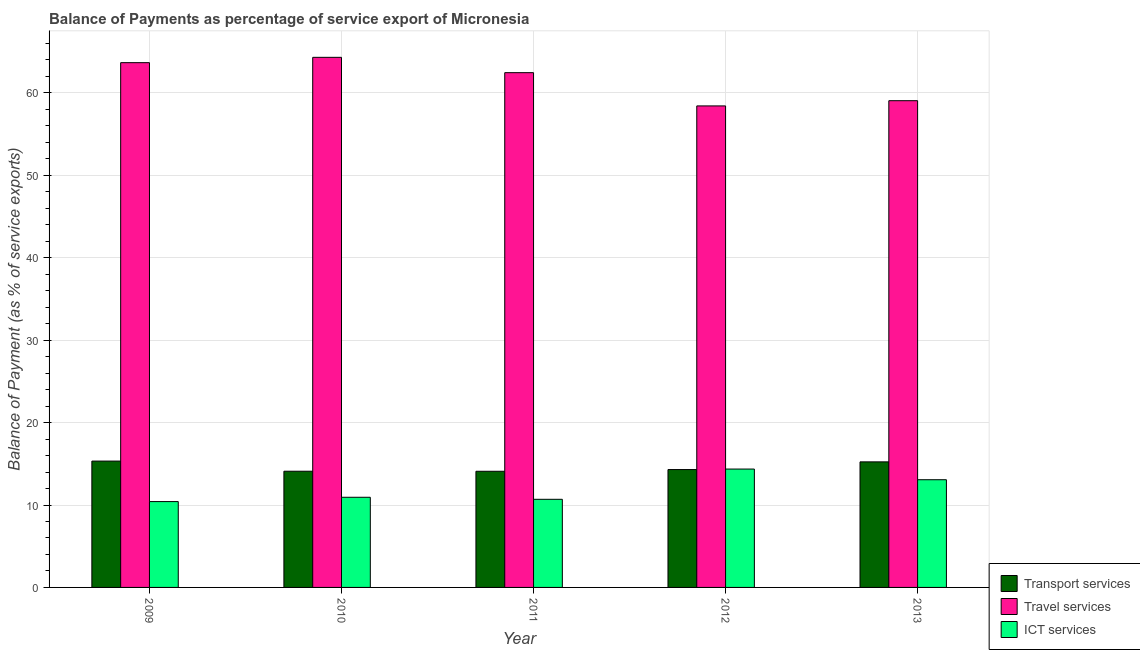How many groups of bars are there?
Offer a terse response. 5. Are the number of bars per tick equal to the number of legend labels?
Keep it short and to the point. Yes. Are the number of bars on each tick of the X-axis equal?
Keep it short and to the point. Yes. How many bars are there on the 3rd tick from the left?
Your answer should be very brief. 3. In how many cases, is the number of bars for a given year not equal to the number of legend labels?
Your response must be concise. 0. What is the balance of payment of travel services in 2013?
Your response must be concise. 59.06. Across all years, what is the maximum balance of payment of ict services?
Your response must be concise. 14.36. Across all years, what is the minimum balance of payment of travel services?
Your answer should be very brief. 58.43. In which year was the balance of payment of ict services minimum?
Give a very brief answer. 2009. What is the total balance of payment of travel services in the graph?
Offer a terse response. 307.94. What is the difference between the balance of payment of transport services in 2011 and that in 2013?
Give a very brief answer. -1.14. What is the difference between the balance of payment of transport services in 2010 and the balance of payment of ict services in 2012?
Keep it short and to the point. -0.2. What is the average balance of payment of travel services per year?
Provide a succinct answer. 61.59. In the year 2010, what is the difference between the balance of payment of travel services and balance of payment of ict services?
Offer a terse response. 0. In how many years, is the balance of payment of ict services greater than 44 %?
Ensure brevity in your answer.  0. What is the ratio of the balance of payment of travel services in 2009 to that in 2010?
Ensure brevity in your answer.  0.99. What is the difference between the highest and the second highest balance of payment of travel services?
Your answer should be compact. 0.65. What is the difference between the highest and the lowest balance of payment of travel services?
Offer a very short reply. 5.89. In how many years, is the balance of payment of transport services greater than the average balance of payment of transport services taken over all years?
Give a very brief answer. 2. Is the sum of the balance of payment of travel services in 2011 and 2013 greater than the maximum balance of payment of ict services across all years?
Offer a very short reply. Yes. What does the 1st bar from the left in 2013 represents?
Provide a succinct answer. Transport services. What does the 2nd bar from the right in 2010 represents?
Offer a terse response. Travel services. How many bars are there?
Give a very brief answer. 15. Are all the bars in the graph horizontal?
Your answer should be compact. No. How many years are there in the graph?
Make the answer very short. 5. What is the difference between two consecutive major ticks on the Y-axis?
Your response must be concise. 10. Does the graph contain grids?
Keep it short and to the point. Yes. What is the title of the graph?
Make the answer very short. Balance of Payments as percentage of service export of Micronesia. Does "Total employers" appear as one of the legend labels in the graph?
Your answer should be very brief. No. What is the label or title of the Y-axis?
Your answer should be compact. Balance of Payment (as % of service exports). What is the Balance of Payment (as % of service exports) in Transport services in 2009?
Your response must be concise. 15.33. What is the Balance of Payment (as % of service exports) in Travel services in 2009?
Offer a terse response. 63.67. What is the Balance of Payment (as % of service exports) of ICT services in 2009?
Offer a very short reply. 10.42. What is the Balance of Payment (as % of service exports) in Transport services in 2010?
Your answer should be compact. 14.1. What is the Balance of Payment (as % of service exports) of Travel services in 2010?
Provide a short and direct response. 64.32. What is the Balance of Payment (as % of service exports) in ICT services in 2010?
Offer a very short reply. 10.94. What is the Balance of Payment (as % of service exports) of Transport services in 2011?
Make the answer very short. 14.09. What is the Balance of Payment (as % of service exports) in Travel services in 2011?
Your response must be concise. 62.46. What is the Balance of Payment (as % of service exports) in ICT services in 2011?
Give a very brief answer. 10.69. What is the Balance of Payment (as % of service exports) of Transport services in 2012?
Ensure brevity in your answer.  14.3. What is the Balance of Payment (as % of service exports) of Travel services in 2012?
Your response must be concise. 58.43. What is the Balance of Payment (as % of service exports) of ICT services in 2012?
Offer a very short reply. 14.36. What is the Balance of Payment (as % of service exports) in Transport services in 2013?
Your response must be concise. 15.23. What is the Balance of Payment (as % of service exports) in Travel services in 2013?
Your answer should be compact. 59.06. What is the Balance of Payment (as % of service exports) in ICT services in 2013?
Provide a short and direct response. 13.07. Across all years, what is the maximum Balance of Payment (as % of service exports) of Transport services?
Your answer should be compact. 15.33. Across all years, what is the maximum Balance of Payment (as % of service exports) in Travel services?
Your answer should be compact. 64.32. Across all years, what is the maximum Balance of Payment (as % of service exports) of ICT services?
Provide a succinct answer. 14.36. Across all years, what is the minimum Balance of Payment (as % of service exports) in Transport services?
Provide a succinct answer. 14.09. Across all years, what is the minimum Balance of Payment (as % of service exports) in Travel services?
Provide a succinct answer. 58.43. Across all years, what is the minimum Balance of Payment (as % of service exports) in ICT services?
Offer a terse response. 10.42. What is the total Balance of Payment (as % of service exports) of Transport services in the graph?
Keep it short and to the point. 73.06. What is the total Balance of Payment (as % of service exports) in Travel services in the graph?
Make the answer very short. 307.94. What is the total Balance of Payment (as % of service exports) in ICT services in the graph?
Ensure brevity in your answer.  59.48. What is the difference between the Balance of Payment (as % of service exports) in Transport services in 2009 and that in 2010?
Offer a very short reply. 1.23. What is the difference between the Balance of Payment (as % of service exports) in Travel services in 2009 and that in 2010?
Your answer should be very brief. -0.65. What is the difference between the Balance of Payment (as % of service exports) in ICT services in 2009 and that in 2010?
Keep it short and to the point. -0.52. What is the difference between the Balance of Payment (as % of service exports) of Transport services in 2009 and that in 2011?
Give a very brief answer. 1.24. What is the difference between the Balance of Payment (as % of service exports) of Travel services in 2009 and that in 2011?
Provide a short and direct response. 1.22. What is the difference between the Balance of Payment (as % of service exports) in ICT services in 2009 and that in 2011?
Make the answer very short. -0.28. What is the difference between the Balance of Payment (as % of service exports) of Transport services in 2009 and that in 2012?
Offer a very short reply. 1.03. What is the difference between the Balance of Payment (as % of service exports) in Travel services in 2009 and that in 2012?
Provide a succinct answer. 5.25. What is the difference between the Balance of Payment (as % of service exports) in ICT services in 2009 and that in 2012?
Your answer should be very brief. -3.95. What is the difference between the Balance of Payment (as % of service exports) in Transport services in 2009 and that in 2013?
Ensure brevity in your answer.  0.1. What is the difference between the Balance of Payment (as % of service exports) of Travel services in 2009 and that in 2013?
Make the answer very short. 4.62. What is the difference between the Balance of Payment (as % of service exports) of ICT services in 2009 and that in 2013?
Your response must be concise. -2.65. What is the difference between the Balance of Payment (as % of service exports) in Transport services in 2010 and that in 2011?
Offer a terse response. 0.01. What is the difference between the Balance of Payment (as % of service exports) in Travel services in 2010 and that in 2011?
Offer a very short reply. 1.86. What is the difference between the Balance of Payment (as % of service exports) of ICT services in 2010 and that in 2011?
Your answer should be compact. 0.25. What is the difference between the Balance of Payment (as % of service exports) of Transport services in 2010 and that in 2012?
Make the answer very short. -0.2. What is the difference between the Balance of Payment (as % of service exports) of Travel services in 2010 and that in 2012?
Make the answer very short. 5.89. What is the difference between the Balance of Payment (as % of service exports) of ICT services in 2010 and that in 2012?
Give a very brief answer. -3.42. What is the difference between the Balance of Payment (as % of service exports) of Transport services in 2010 and that in 2013?
Give a very brief answer. -1.14. What is the difference between the Balance of Payment (as % of service exports) in Travel services in 2010 and that in 2013?
Your answer should be compact. 5.26. What is the difference between the Balance of Payment (as % of service exports) in ICT services in 2010 and that in 2013?
Ensure brevity in your answer.  -2.13. What is the difference between the Balance of Payment (as % of service exports) of Transport services in 2011 and that in 2012?
Offer a very short reply. -0.21. What is the difference between the Balance of Payment (as % of service exports) of Travel services in 2011 and that in 2012?
Provide a succinct answer. 4.03. What is the difference between the Balance of Payment (as % of service exports) of ICT services in 2011 and that in 2012?
Your answer should be compact. -3.67. What is the difference between the Balance of Payment (as % of service exports) in Transport services in 2011 and that in 2013?
Provide a short and direct response. -1.14. What is the difference between the Balance of Payment (as % of service exports) in Travel services in 2011 and that in 2013?
Provide a short and direct response. 3.4. What is the difference between the Balance of Payment (as % of service exports) of ICT services in 2011 and that in 2013?
Offer a terse response. -2.38. What is the difference between the Balance of Payment (as % of service exports) in Transport services in 2012 and that in 2013?
Provide a succinct answer. -0.93. What is the difference between the Balance of Payment (as % of service exports) of Travel services in 2012 and that in 2013?
Give a very brief answer. -0.63. What is the difference between the Balance of Payment (as % of service exports) in ICT services in 2012 and that in 2013?
Provide a short and direct response. 1.29. What is the difference between the Balance of Payment (as % of service exports) of Transport services in 2009 and the Balance of Payment (as % of service exports) of Travel services in 2010?
Offer a terse response. -48.99. What is the difference between the Balance of Payment (as % of service exports) of Transport services in 2009 and the Balance of Payment (as % of service exports) of ICT services in 2010?
Your answer should be compact. 4.39. What is the difference between the Balance of Payment (as % of service exports) in Travel services in 2009 and the Balance of Payment (as % of service exports) in ICT services in 2010?
Make the answer very short. 52.74. What is the difference between the Balance of Payment (as % of service exports) of Transport services in 2009 and the Balance of Payment (as % of service exports) of Travel services in 2011?
Your response must be concise. -47.13. What is the difference between the Balance of Payment (as % of service exports) of Transport services in 2009 and the Balance of Payment (as % of service exports) of ICT services in 2011?
Your response must be concise. 4.64. What is the difference between the Balance of Payment (as % of service exports) of Travel services in 2009 and the Balance of Payment (as % of service exports) of ICT services in 2011?
Your response must be concise. 52.98. What is the difference between the Balance of Payment (as % of service exports) in Transport services in 2009 and the Balance of Payment (as % of service exports) in Travel services in 2012?
Your answer should be compact. -43.1. What is the difference between the Balance of Payment (as % of service exports) in Transport services in 2009 and the Balance of Payment (as % of service exports) in ICT services in 2012?
Make the answer very short. 0.97. What is the difference between the Balance of Payment (as % of service exports) in Travel services in 2009 and the Balance of Payment (as % of service exports) in ICT services in 2012?
Your response must be concise. 49.31. What is the difference between the Balance of Payment (as % of service exports) of Transport services in 2009 and the Balance of Payment (as % of service exports) of Travel services in 2013?
Your response must be concise. -43.73. What is the difference between the Balance of Payment (as % of service exports) of Transport services in 2009 and the Balance of Payment (as % of service exports) of ICT services in 2013?
Your answer should be very brief. 2.26. What is the difference between the Balance of Payment (as % of service exports) of Travel services in 2009 and the Balance of Payment (as % of service exports) of ICT services in 2013?
Offer a terse response. 50.61. What is the difference between the Balance of Payment (as % of service exports) in Transport services in 2010 and the Balance of Payment (as % of service exports) in Travel services in 2011?
Keep it short and to the point. -48.36. What is the difference between the Balance of Payment (as % of service exports) in Transport services in 2010 and the Balance of Payment (as % of service exports) in ICT services in 2011?
Keep it short and to the point. 3.41. What is the difference between the Balance of Payment (as % of service exports) in Travel services in 2010 and the Balance of Payment (as % of service exports) in ICT services in 2011?
Offer a very short reply. 53.63. What is the difference between the Balance of Payment (as % of service exports) of Transport services in 2010 and the Balance of Payment (as % of service exports) of Travel services in 2012?
Offer a terse response. -44.33. What is the difference between the Balance of Payment (as % of service exports) of Transport services in 2010 and the Balance of Payment (as % of service exports) of ICT services in 2012?
Provide a succinct answer. -0.26. What is the difference between the Balance of Payment (as % of service exports) of Travel services in 2010 and the Balance of Payment (as % of service exports) of ICT services in 2012?
Your answer should be very brief. 49.96. What is the difference between the Balance of Payment (as % of service exports) in Transport services in 2010 and the Balance of Payment (as % of service exports) in Travel services in 2013?
Your answer should be very brief. -44.96. What is the difference between the Balance of Payment (as % of service exports) in Transport services in 2010 and the Balance of Payment (as % of service exports) in ICT services in 2013?
Provide a short and direct response. 1.03. What is the difference between the Balance of Payment (as % of service exports) of Travel services in 2010 and the Balance of Payment (as % of service exports) of ICT services in 2013?
Ensure brevity in your answer.  51.25. What is the difference between the Balance of Payment (as % of service exports) in Transport services in 2011 and the Balance of Payment (as % of service exports) in Travel services in 2012?
Ensure brevity in your answer.  -44.33. What is the difference between the Balance of Payment (as % of service exports) of Transport services in 2011 and the Balance of Payment (as % of service exports) of ICT services in 2012?
Offer a terse response. -0.27. What is the difference between the Balance of Payment (as % of service exports) of Travel services in 2011 and the Balance of Payment (as % of service exports) of ICT services in 2012?
Make the answer very short. 48.1. What is the difference between the Balance of Payment (as % of service exports) of Transport services in 2011 and the Balance of Payment (as % of service exports) of Travel services in 2013?
Your answer should be compact. -44.96. What is the difference between the Balance of Payment (as % of service exports) of Transport services in 2011 and the Balance of Payment (as % of service exports) of ICT services in 2013?
Your answer should be compact. 1.03. What is the difference between the Balance of Payment (as % of service exports) of Travel services in 2011 and the Balance of Payment (as % of service exports) of ICT services in 2013?
Your answer should be compact. 49.39. What is the difference between the Balance of Payment (as % of service exports) in Transport services in 2012 and the Balance of Payment (as % of service exports) in Travel services in 2013?
Give a very brief answer. -44.76. What is the difference between the Balance of Payment (as % of service exports) in Transport services in 2012 and the Balance of Payment (as % of service exports) in ICT services in 2013?
Make the answer very short. 1.23. What is the difference between the Balance of Payment (as % of service exports) of Travel services in 2012 and the Balance of Payment (as % of service exports) of ICT services in 2013?
Keep it short and to the point. 45.36. What is the average Balance of Payment (as % of service exports) in Transport services per year?
Your answer should be very brief. 14.61. What is the average Balance of Payment (as % of service exports) in Travel services per year?
Offer a very short reply. 61.59. What is the average Balance of Payment (as % of service exports) in ICT services per year?
Offer a very short reply. 11.9. In the year 2009, what is the difference between the Balance of Payment (as % of service exports) in Transport services and Balance of Payment (as % of service exports) in Travel services?
Your answer should be very brief. -48.34. In the year 2009, what is the difference between the Balance of Payment (as % of service exports) in Transport services and Balance of Payment (as % of service exports) in ICT services?
Ensure brevity in your answer.  4.91. In the year 2009, what is the difference between the Balance of Payment (as % of service exports) in Travel services and Balance of Payment (as % of service exports) in ICT services?
Your response must be concise. 53.26. In the year 2010, what is the difference between the Balance of Payment (as % of service exports) in Transport services and Balance of Payment (as % of service exports) in Travel services?
Offer a terse response. -50.22. In the year 2010, what is the difference between the Balance of Payment (as % of service exports) in Transport services and Balance of Payment (as % of service exports) in ICT services?
Offer a very short reply. 3.16. In the year 2010, what is the difference between the Balance of Payment (as % of service exports) of Travel services and Balance of Payment (as % of service exports) of ICT services?
Your answer should be very brief. 53.38. In the year 2011, what is the difference between the Balance of Payment (as % of service exports) in Transport services and Balance of Payment (as % of service exports) in Travel services?
Your answer should be compact. -48.36. In the year 2011, what is the difference between the Balance of Payment (as % of service exports) in Transport services and Balance of Payment (as % of service exports) in ICT services?
Your response must be concise. 3.4. In the year 2011, what is the difference between the Balance of Payment (as % of service exports) in Travel services and Balance of Payment (as % of service exports) in ICT services?
Your response must be concise. 51.77. In the year 2012, what is the difference between the Balance of Payment (as % of service exports) of Transport services and Balance of Payment (as % of service exports) of Travel services?
Keep it short and to the point. -44.12. In the year 2012, what is the difference between the Balance of Payment (as % of service exports) in Transport services and Balance of Payment (as % of service exports) in ICT services?
Your answer should be very brief. -0.06. In the year 2012, what is the difference between the Balance of Payment (as % of service exports) in Travel services and Balance of Payment (as % of service exports) in ICT services?
Your answer should be very brief. 44.06. In the year 2013, what is the difference between the Balance of Payment (as % of service exports) in Transport services and Balance of Payment (as % of service exports) in Travel services?
Offer a terse response. -43.82. In the year 2013, what is the difference between the Balance of Payment (as % of service exports) of Transport services and Balance of Payment (as % of service exports) of ICT services?
Provide a succinct answer. 2.17. In the year 2013, what is the difference between the Balance of Payment (as % of service exports) of Travel services and Balance of Payment (as % of service exports) of ICT services?
Your response must be concise. 45.99. What is the ratio of the Balance of Payment (as % of service exports) of Transport services in 2009 to that in 2010?
Provide a short and direct response. 1.09. What is the ratio of the Balance of Payment (as % of service exports) of ICT services in 2009 to that in 2010?
Provide a short and direct response. 0.95. What is the ratio of the Balance of Payment (as % of service exports) in Transport services in 2009 to that in 2011?
Keep it short and to the point. 1.09. What is the ratio of the Balance of Payment (as % of service exports) of Travel services in 2009 to that in 2011?
Provide a short and direct response. 1.02. What is the ratio of the Balance of Payment (as % of service exports) of ICT services in 2009 to that in 2011?
Give a very brief answer. 0.97. What is the ratio of the Balance of Payment (as % of service exports) of Transport services in 2009 to that in 2012?
Your response must be concise. 1.07. What is the ratio of the Balance of Payment (as % of service exports) in Travel services in 2009 to that in 2012?
Your answer should be very brief. 1.09. What is the ratio of the Balance of Payment (as % of service exports) in ICT services in 2009 to that in 2012?
Give a very brief answer. 0.73. What is the ratio of the Balance of Payment (as % of service exports) in Transport services in 2009 to that in 2013?
Provide a short and direct response. 1.01. What is the ratio of the Balance of Payment (as % of service exports) of Travel services in 2009 to that in 2013?
Keep it short and to the point. 1.08. What is the ratio of the Balance of Payment (as % of service exports) in ICT services in 2009 to that in 2013?
Provide a succinct answer. 0.8. What is the ratio of the Balance of Payment (as % of service exports) of Travel services in 2010 to that in 2011?
Your response must be concise. 1.03. What is the ratio of the Balance of Payment (as % of service exports) of Transport services in 2010 to that in 2012?
Your response must be concise. 0.99. What is the ratio of the Balance of Payment (as % of service exports) of Travel services in 2010 to that in 2012?
Ensure brevity in your answer.  1.1. What is the ratio of the Balance of Payment (as % of service exports) of ICT services in 2010 to that in 2012?
Provide a short and direct response. 0.76. What is the ratio of the Balance of Payment (as % of service exports) of Transport services in 2010 to that in 2013?
Your response must be concise. 0.93. What is the ratio of the Balance of Payment (as % of service exports) in Travel services in 2010 to that in 2013?
Give a very brief answer. 1.09. What is the ratio of the Balance of Payment (as % of service exports) of ICT services in 2010 to that in 2013?
Make the answer very short. 0.84. What is the ratio of the Balance of Payment (as % of service exports) of Transport services in 2011 to that in 2012?
Your response must be concise. 0.99. What is the ratio of the Balance of Payment (as % of service exports) of Travel services in 2011 to that in 2012?
Give a very brief answer. 1.07. What is the ratio of the Balance of Payment (as % of service exports) of ICT services in 2011 to that in 2012?
Your answer should be very brief. 0.74. What is the ratio of the Balance of Payment (as % of service exports) in Transport services in 2011 to that in 2013?
Your answer should be compact. 0.93. What is the ratio of the Balance of Payment (as % of service exports) in Travel services in 2011 to that in 2013?
Your response must be concise. 1.06. What is the ratio of the Balance of Payment (as % of service exports) in ICT services in 2011 to that in 2013?
Ensure brevity in your answer.  0.82. What is the ratio of the Balance of Payment (as % of service exports) of Transport services in 2012 to that in 2013?
Give a very brief answer. 0.94. What is the ratio of the Balance of Payment (as % of service exports) in Travel services in 2012 to that in 2013?
Provide a short and direct response. 0.99. What is the ratio of the Balance of Payment (as % of service exports) of ICT services in 2012 to that in 2013?
Your answer should be compact. 1.1. What is the difference between the highest and the second highest Balance of Payment (as % of service exports) in Transport services?
Your answer should be very brief. 0.1. What is the difference between the highest and the second highest Balance of Payment (as % of service exports) in Travel services?
Keep it short and to the point. 0.65. What is the difference between the highest and the second highest Balance of Payment (as % of service exports) of ICT services?
Give a very brief answer. 1.29. What is the difference between the highest and the lowest Balance of Payment (as % of service exports) of Transport services?
Provide a succinct answer. 1.24. What is the difference between the highest and the lowest Balance of Payment (as % of service exports) of Travel services?
Provide a succinct answer. 5.89. What is the difference between the highest and the lowest Balance of Payment (as % of service exports) in ICT services?
Your answer should be very brief. 3.95. 